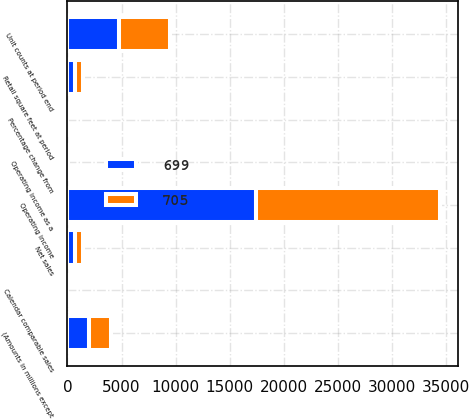Convert chart to OTSL. <chart><loc_0><loc_0><loc_500><loc_500><stacked_bar_chart><ecel><fcel>(Amounts in millions except<fcel>Net sales<fcel>Percentage change from<fcel>Calendar comparable sales<fcel>Operating income<fcel>Operating income as a<fcel>Unit counts at period end<fcel>Retail square feet at period<nl><fcel>699<fcel>2019<fcel>702<fcel>4.1<fcel>3.7<fcel>17386<fcel>5.2<fcel>4769<fcel>705<nl><fcel>705<fcel>2017<fcel>702<fcel>3.2<fcel>1.6<fcel>17012<fcel>5.5<fcel>4672<fcel>699<nl></chart> 